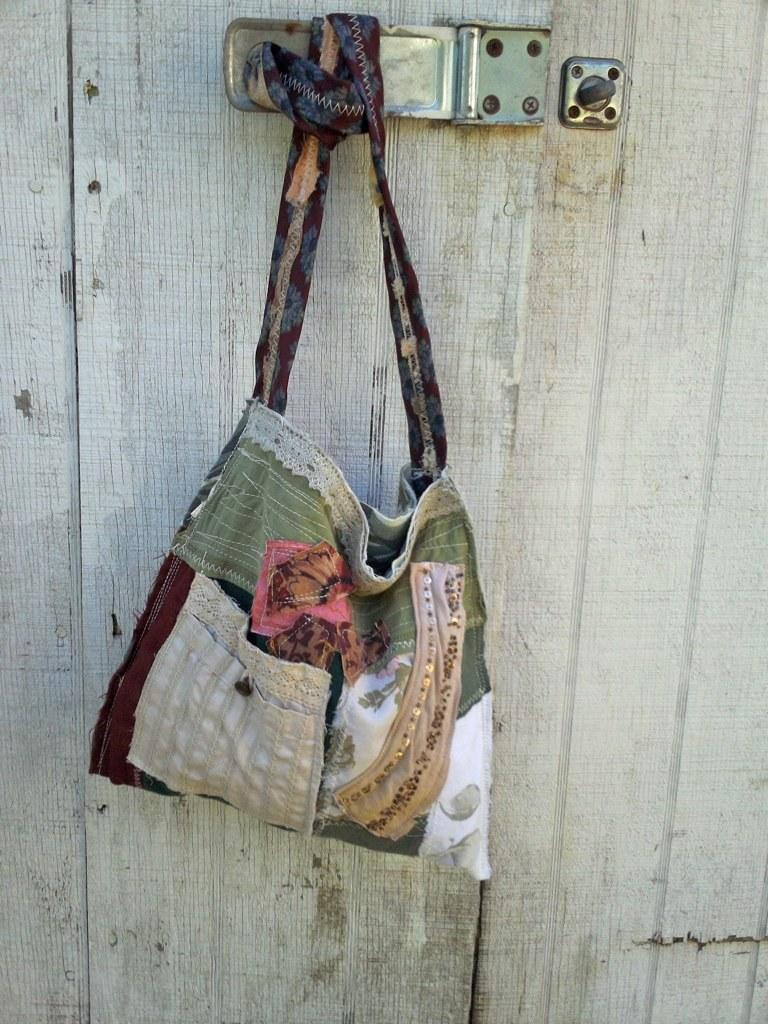What type of bag is visible in the image? There is a cloth bag in the image. How is the cloth bag attached to something else? The cloth bag is tied to a handle. What can be seen in the background of the image? There is a wooden door in the background of the image. What type of street is visible in the image? There is no street visible in the image; it only features a cloth bag tied to a handle and a wooden door in the background. 